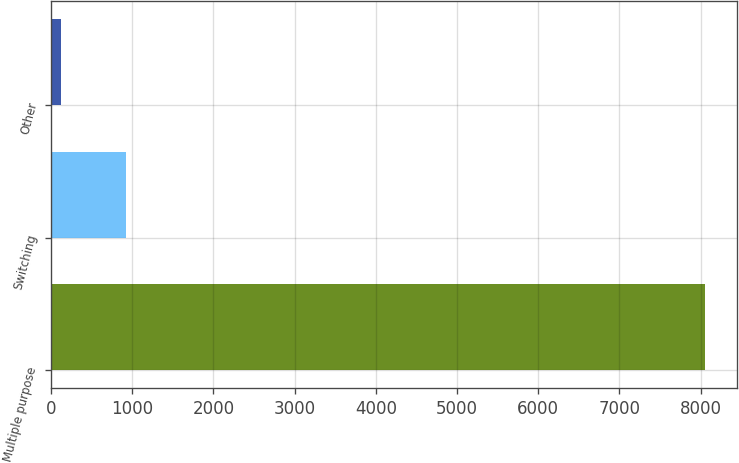Convert chart to OTSL. <chart><loc_0><loc_0><loc_500><loc_500><bar_chart><fcel>Multiple purpose<fcel>Switching<fcel>Other<nl><fcel>8052<fcel>919.5<fcel>127<nl></chart> 